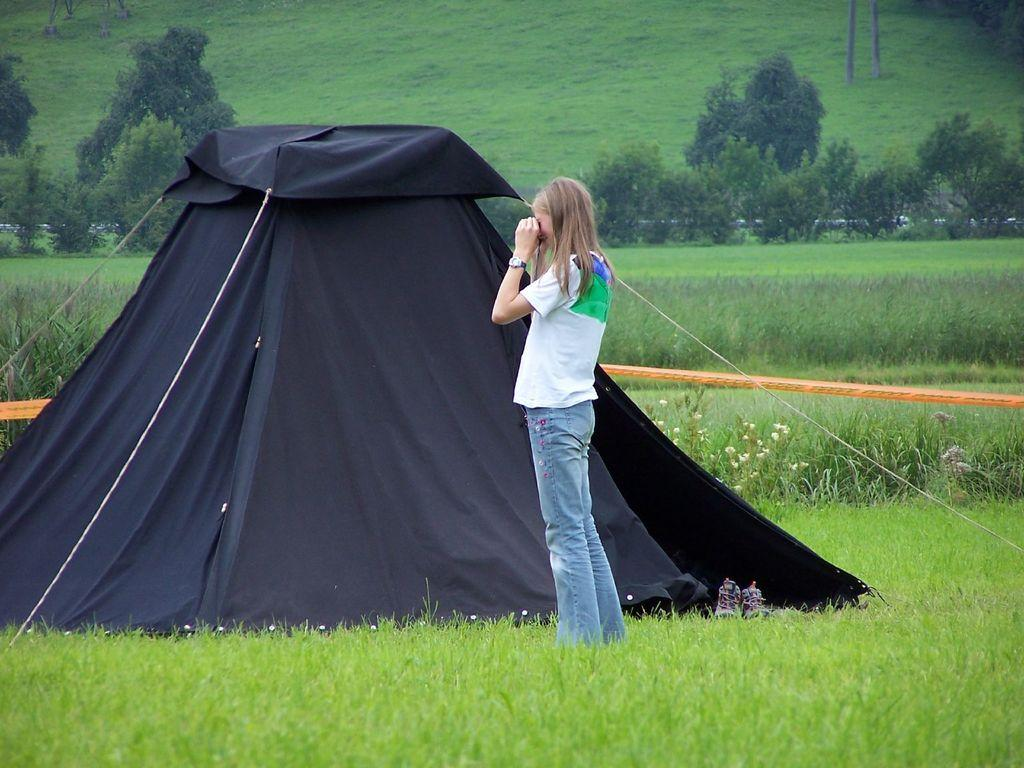What is the overall color tint of the image? The image has a black color tint. What is the woman in the image doing? The woman is standing on the ground in the image. What type of vegetation can be seen in the background of the image? Grass, plants, and trees are visible in the background of the image. What else can be seen in the background of the image? There are other objects in the background of the image. How many boys are playing in the quicksand in the image? There are no boys or quicksand present in the image. Who created the image? The creator of the image is not mentioned in the provided facts. 